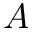Convert formula to latex. <formula><loc_0><loc_0><loc_500><loc_500>A</formula> 